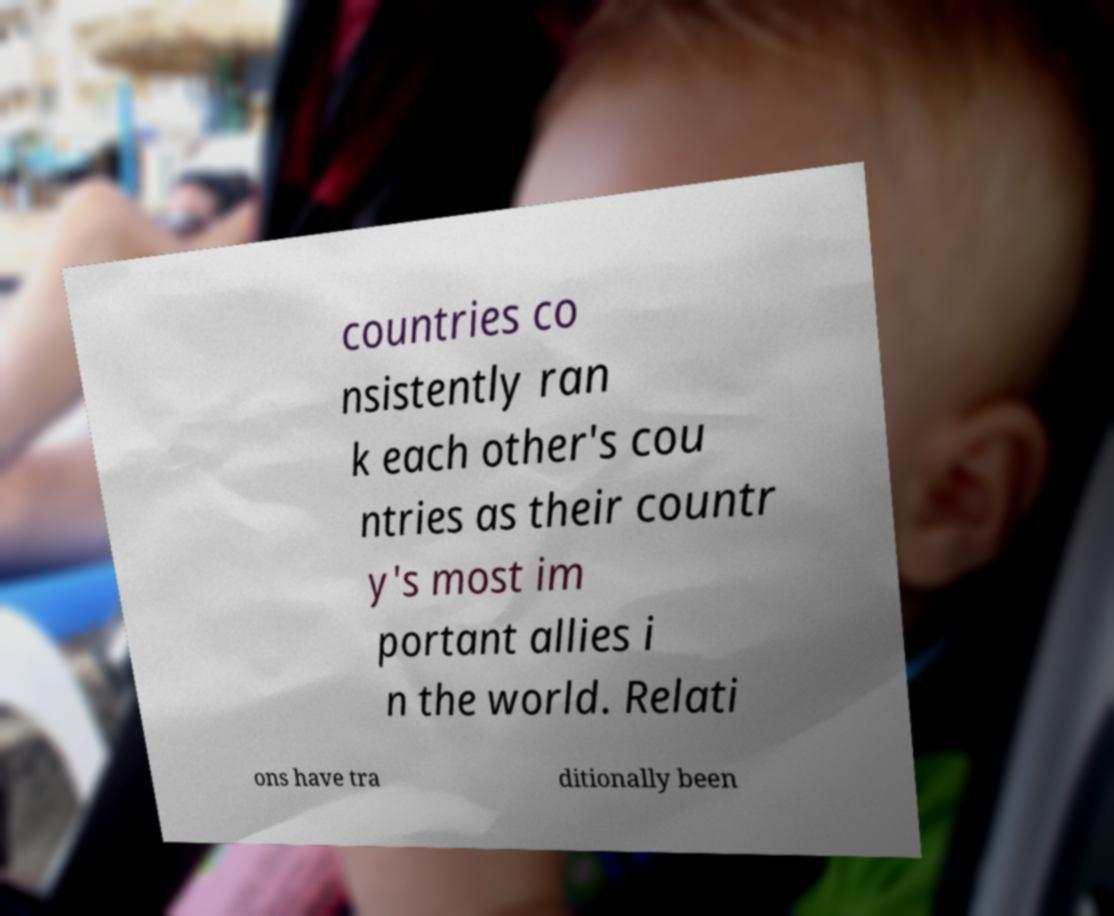There's text embedded in this image that I need extracted. Can you transcribe it verbatim? countries co nsistently ran k each other's cou ntries as their countr y's most im portant allies i n the world. Relati ons have tra ditionally been 